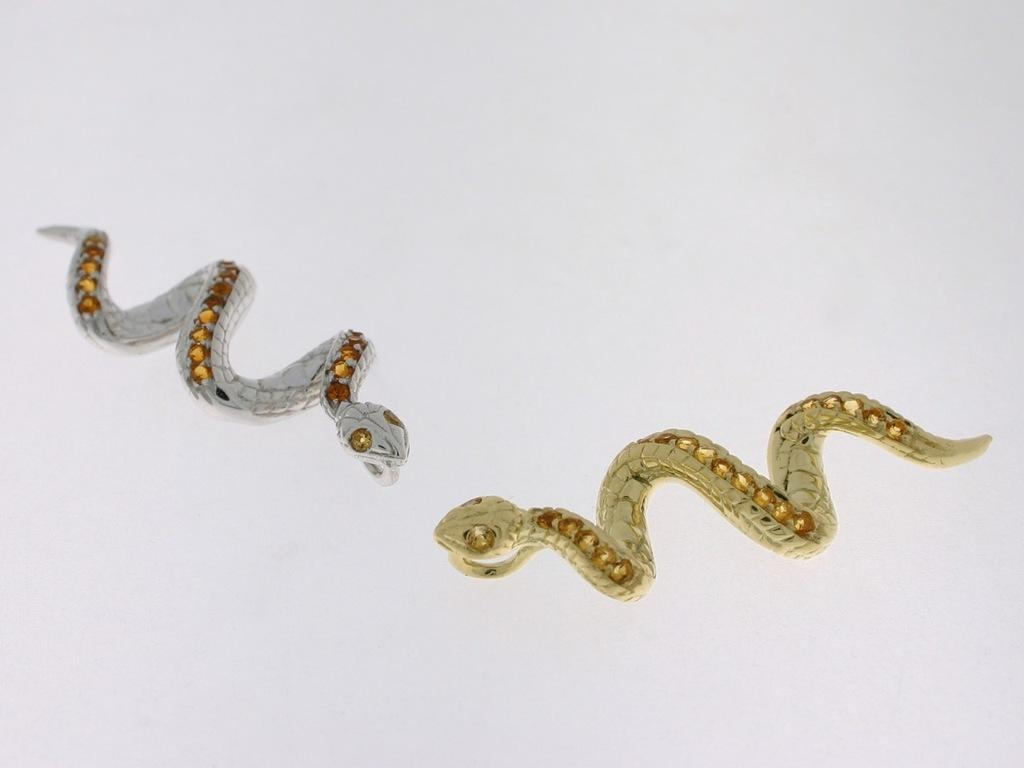How many snakes are present in the image? There are two snakes in the image. What can be inferred about the nature of the snakes? The snakes appear to be artificial objects. What colors are the snakes? One snake is gold in color, and the other snake is silver in color. What type of food is being prepared in the field in the image? There is no food or field present in the image; it features two artificial snakes. Can you see an owl perched on one of the snakes in the image? There is no owl present in the image. 